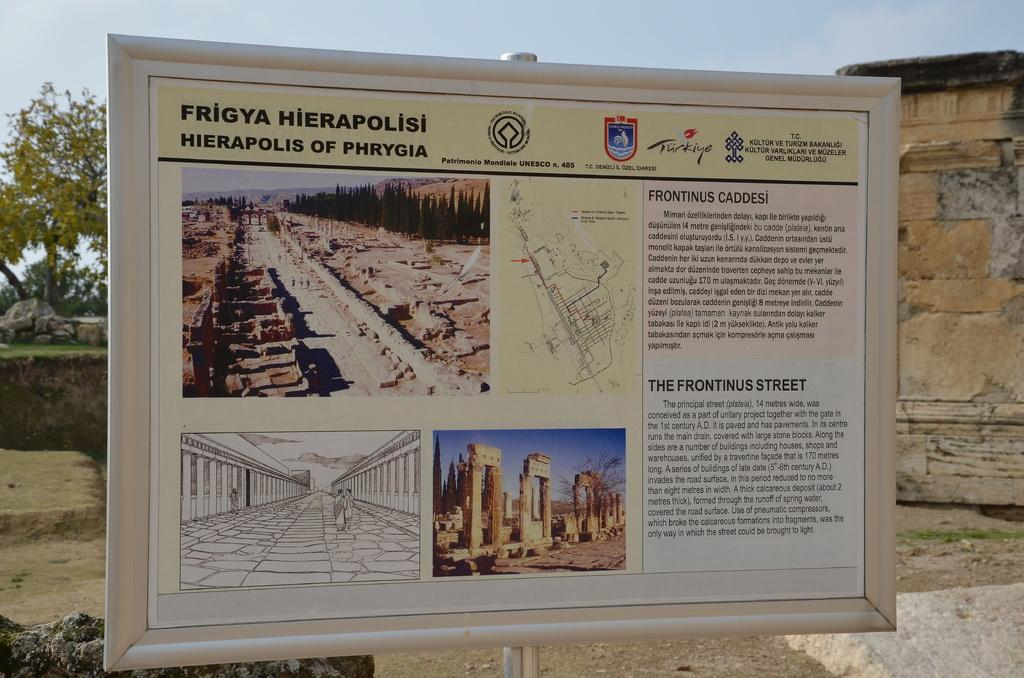What is the main subject of the image? The main subject of the image is a board with images and text. What can be seen in the background of the image? There is a wall, the ground, grass, rocks, trees, and the sky visible in the image. What type of nail is being used to hang the board in the image? There is no nail present in the image. The board is not hanging in the image. 